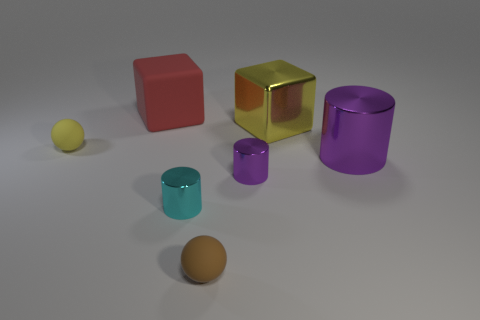There is a small ball that is the same color as the large metal cube; what material is it?
Ensure brevity in your answer.  Rubber. What shape is the tiny rubber object behind the tiny ball that is in front of the tiny sphere behind the cyan object?
Your answer should be very brief. Sphere. What material is the other thing that is the same shape as the big yellow object?
Offer a terse response. Rubber. How many green matte cylinders are there?
Give a very brief answer. 0. The tiny brown rubber thing that is right of the small cyan shiny cylinder has what shape?
Make the answer very short. Sphere. There is a rubber object in front of the yellow object that is to the left of the cyan metal thing that is left of the big cylinder; what color is it?
Give a very brief answer. Brown. What is the shape of the brown thing that is made of the same material as the small yellow ball?
Make the answer very short. Sphere. Are there fewer tiny green rubber blocks than tiny cyan objects?
Provide a short and direct response. Yes. Does the tiny brown sphere have the same material as the yellow ball?
Provide a succinct answer. Yes. How many other things are there of the same color as the big rubber object?
Give a very brief answer. 0. 